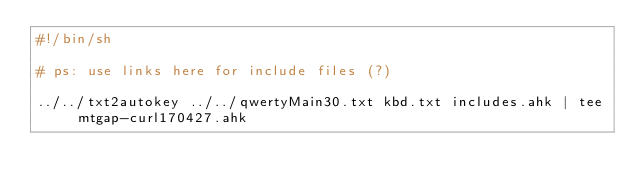Convert code to text. <code><loc_0><loc_0><loc_500><loc_500><_Bash_>#!/bin/sh

# ps: use links here for include files (?)

../../txt2autokey ../../qwertyMain30.txt kbd.txt includes.ahk | tee mtgap-curl170427.ahk
</code> 